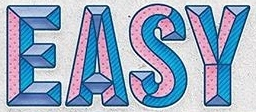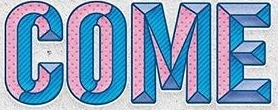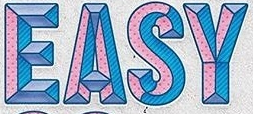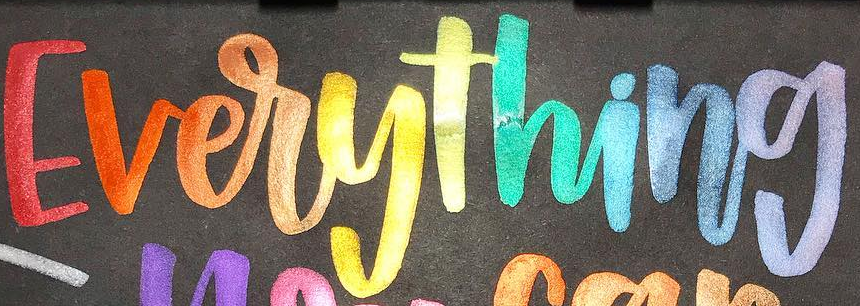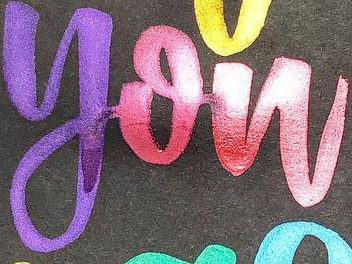What words can you see in these images in sequence, separated by a semicolon? EASY; COME; EASY; Everything; you 